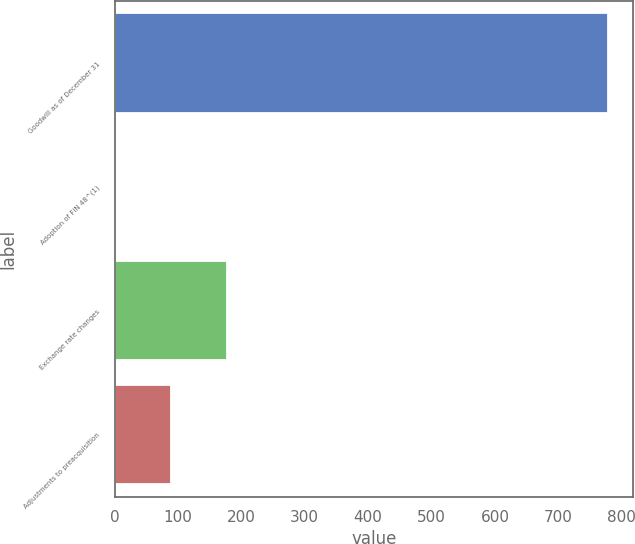<chart> <loc_0><loc_0><loc_500><loc_500><bar_chart><fcel>Goodwill as of December 31<fcel>Adoption of FIN 48^(1)<fcel>Exchange rate changes<fcel>Adjustments to preacquisition<nl><fcel>779<fcel>2<fcel>176.6<fcel>89.3<nl></chart> 